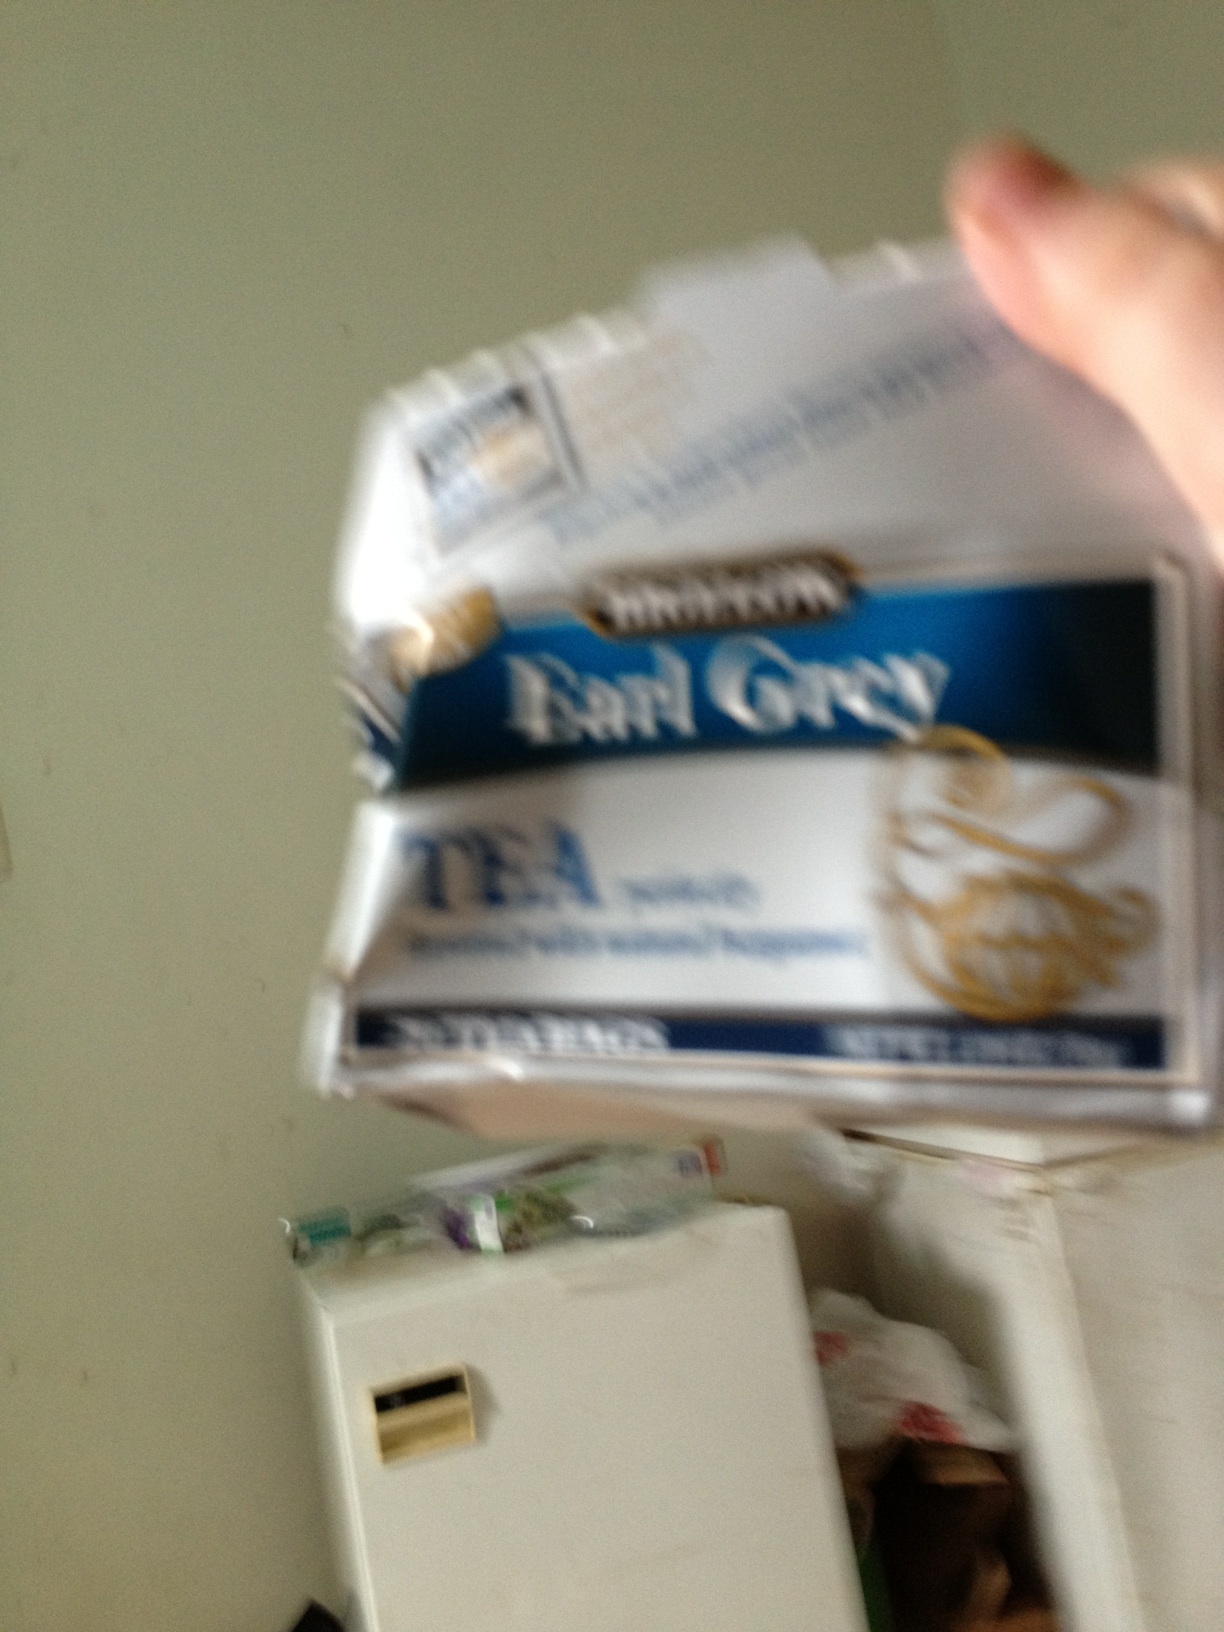What's the history behind Earl Grey tea? Earl Grey tea is named after the 2nd Earl Grey, Charles Grey, who was the Prime Minister of the United Kingdom in the early 19th century. Legend has it that the tea was a gift from a Chinese mandarin to Earl Grey, as a gesture of thanks for saving the mandarin's son. The original recipe is said to have used bergamot oil to offset the preponderance of lime in the local water at the Earl's estate, which resulted in the distinctive tea blend we know today. While this story is not verifiable, Earl Grey tea nevertheless remains one of the most popular flavored teas in the world. 